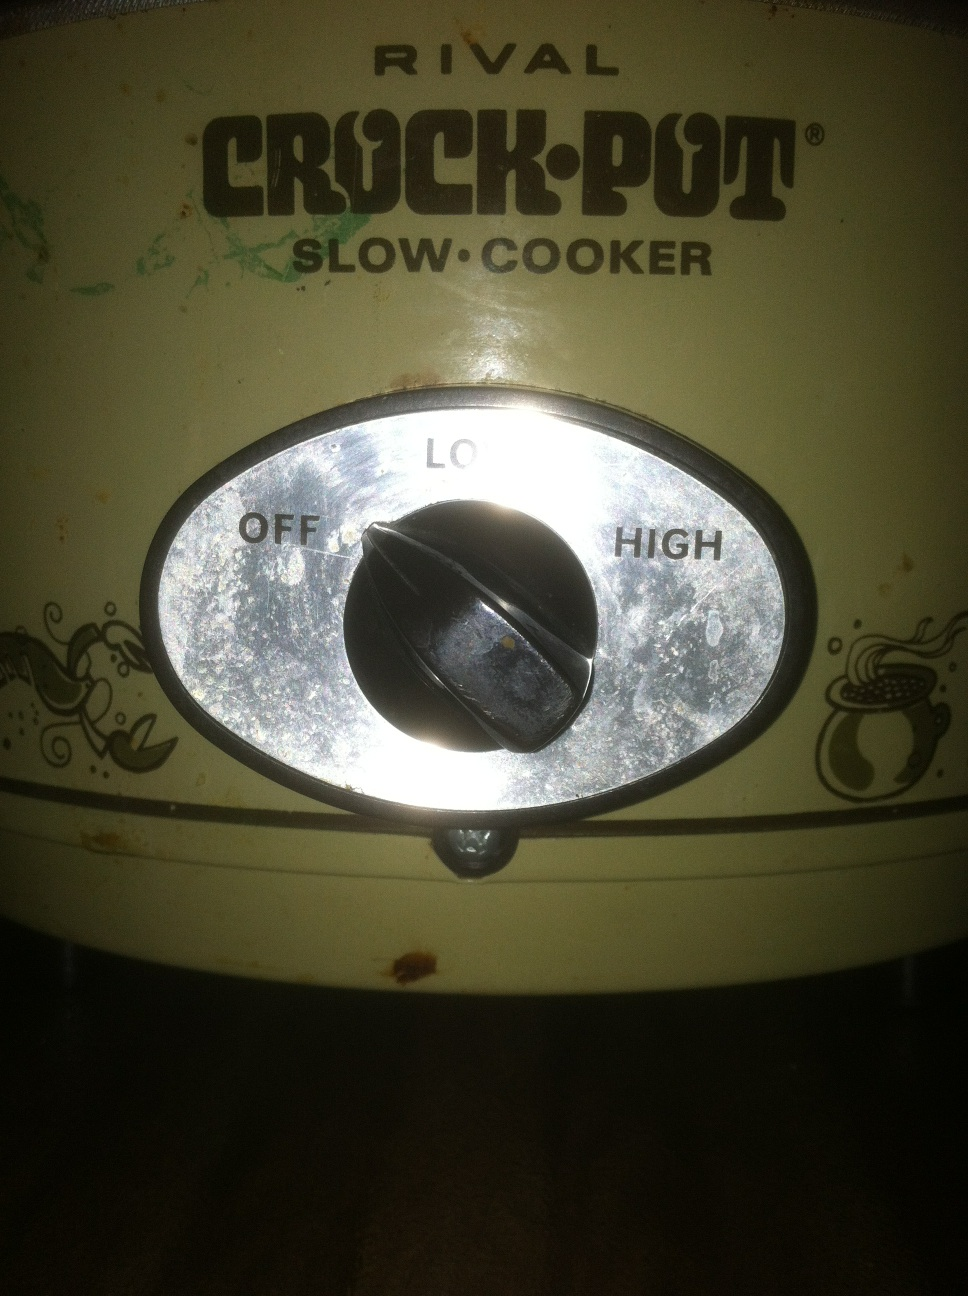Tell me a unique way to use this crock pot. A creative way to use a crock pot is to make homemade candles. Melting wax can be messy and dangerous, but using a crock pot provides a controlled, low heat which is perfect for the task. You'll just need some paraffin wax, essential oils for scent, and some wicks. Melt the wax, add your scents, and pour it into molds with the wicks in place. Can it make yogurt? Absolutely! Making yogurt in a crock pot is quite simple. Heat a quart of milk in the crock pot on low until it reaches about 180°F, then turn off the heat and let it cool to 110°F. Stir in a few tablespoons of plain yogurt as a starter. Wrap the crock pot in a bath towel to keep it warm and let it sit for 8-12 hours. The result is fresh homemade yogurt. 